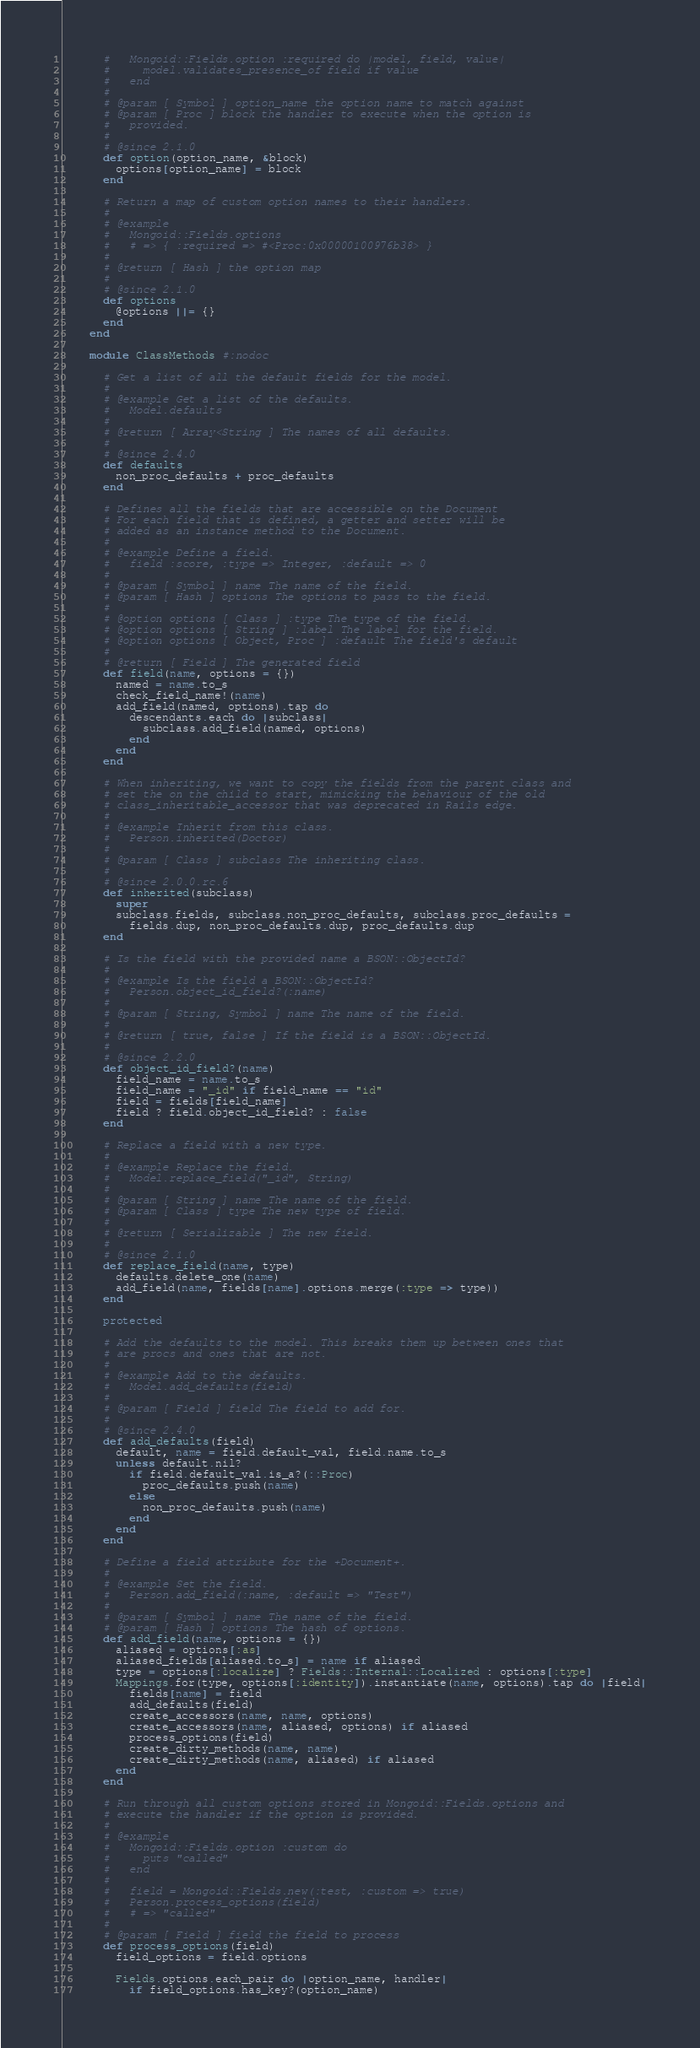Convert code to text. <code><loc_0><loc_0><loc_500><loc_500><_Ruby_>      #   Mongoid::Fields.option :required do |model, field, value|
      #     model.validates_presence_of field if value
      #   end
      #
      # @param [ Symbol ] option_name the option name to match against
      # @param [ Proc ] block the handler to execute when the option is
      #   provided.
      #
      # @since 2.1.0
      def option(option_name, &block)
        options[option_name] = block
      end

      # Return a map of custom option names to their handlers.
      #
      # @example
      #   Mongoid::Fields.options
      #   # => { :required => #<Proc:0x00000100976b38> }
      #
      # @return [ Hash ] the option map
      #
      # @since 2.1.0
      def options
        @options ||= {}
      end
    end

    module ClassMethods #:nodoc

      # Get a list of all the default fields for the model.
      #
      # @example Get a list of the defaults.
      #   Model.defaults
      #
      # @return [ Array<String ] The names of all defaults.
      #
      # @since 2.4.0
      def defaults
        non_proc_defaults + proc_defaults
      end

      # Defines all the fields that are accessible on the Document
      # For each field that is defined, a getter and setter will be
      # added as an instance method to the Document.
      #
      # @example Define a field.
      #   field :score, :type => Integer, :default => 0
      #
      # @param [ Symbol ] name The name of the field.
      # @param [ Hash ] options The options to pass to the field.
      #
      # @option options [ Class ] :type The type of the field.
      # @option options [ String ] :label The label for the field.
      # @option options [ Object, Proc ] :default The field's default
      #
      # @return [ Field ] The generated field
      def field(name, options = {})
        named = name.to_s
        check_field_name!(name)
        add_field(named, options).tap do
          descendants.each do |subclass|
            subclass.add_field(named, options)
          end
        end
      end

      # When inheriting, we want to copy the fields from the parent class and
      # set the on the child to start, mimicking the behaviour of the old
      # class_inheritable_accessor that was deprecated in Rails edge.
      #
      # @example Inherit from this class.
      #   Person.inherited(Doctor)
      #
      # @param [ Class ] subclass The inheriting class.
      #
      # @since 2.0.0.rc.6
      def inherited(subclass)
        super
        subclass.fields, subclass.non_proc_defaults, subclass.proc_defaults =
          fields.dup, non_proc_defaults.dup, proc_defaults.dup
      end

      # Is the field with the provided name a BSON::ObjectId?
      #
      # @example Is the field a BSON::ObjectId?
      #   Person.object_id_field?(:name)
      #
      # @param [ String, Symbol ] name The name of the field.
      #
      # @return [ true, false ] If the field is a BSON::ObjectId.
      #
      # @since 2.2.0
      def object_id_field?(name)
        field_name = name.to_s
        field_name = "_id" if field_name == "id"
        field = fields[field_name]
        field ? field.object_id_field? : false
      end

      # Replace a field with a new type.
      #
      # @example Replace the field.
      #   Model.replace_field("_id", String)
      #
      # @param [ String ] name The name of the field.
      # @param [ Class ] type The new type of field.
      #
      # @return [ Serializable ] The new field.
      #
      # @since 2.1.0
      def replace_field(name, type)
        defaults.delete_one(name)
        add_field(name, fields[name].options.merge(:type => type))
      end

      protected

      # Add the defaults to the model. This breaks them up between ones that
      # are procs and ones that are not.
      #
      # @example Add to the defaults.
      #   Model.add_defaults(field)
      #
      # @param [ Field ] field The field to add for.
      #
      # @since 2.4.0
      def add_defaults(field)
        default, name = field.default_val, field.name.to_s
        unless default.nil?
          if field.default_val.is_a?(::Proc)
            proc_defaults.push(name)
          else
            non_proc_defaults.push(name)
          end
        end
      end

      # Define a field attribute for the +Document+.
      #
      # @example Set the field.
      #   Person.add_field(:name, :default => "Test")
      #
      # @param [ Symbol ] name The name of the field.
      # @param [ Hash ] options The hash of options.
      def add_field(name, options = {})
        aliased = options[:as]
        aliased_fields[aliased.to_s] = name if aliased
        type = options[:localize] ? Fields::Internal::Localized : options[:type]
        Mappings.for(type, options[:identity]).instantiate(name, options).tap do |field|
          fields[name] = field
          add_defaults(field)
          create_accessors(name, name, options)
          create_accessors(name, aliased, options) if aliased
          process_options(field)
          create_dirty_methods(name, name)
          create_dirty_methods(name, aliased) if aliased
        end
      end

      # Run through all custom options stored in Mongoid::Fields.options and
      # execute the handler if the option is provided.
      #
      # @example
      #   Mongoid::Fields.option :custom do
      #     puts "called"
      #   end
      #
      #   field = Mongoid::Fields.new(:test, :custom => true)
      #   Person.process_options(field)
      #   # => "called"
      #
      # @param [ Field ] field the field to process
      def process_options(field)
        field_options = field.options

        Fields.options.each_pair do |option_name, handler|
          if field_options.has_key?(option_name)</code> 